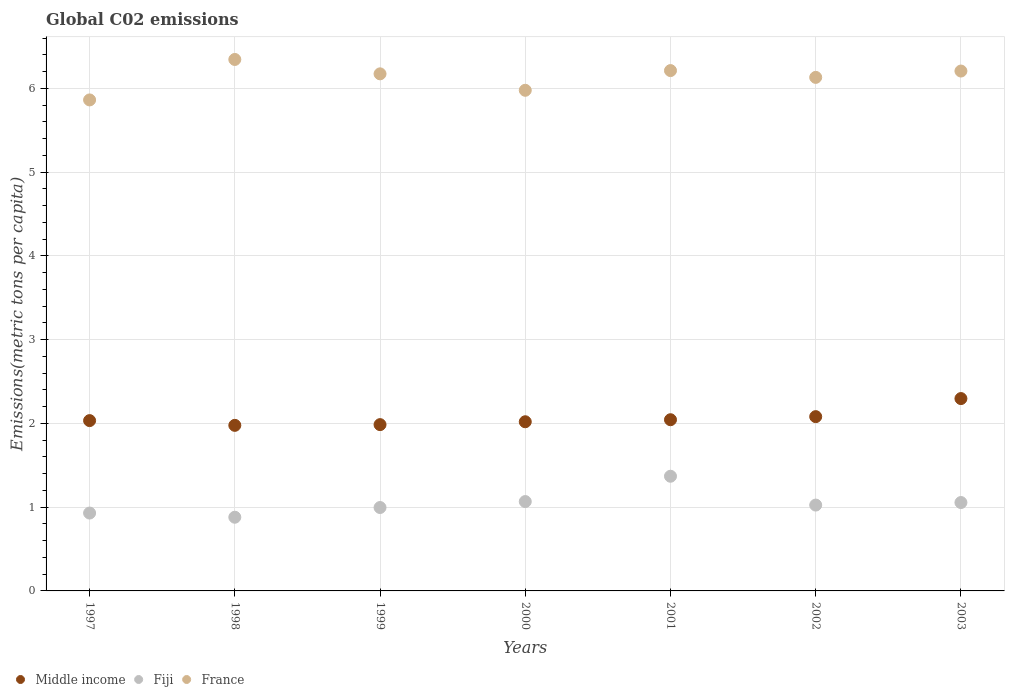How many different coloured dotlines are there?
Make the answer very short. 3. What is the amount of CO2 emitted in in Middle income in 2002?
Offer a terse response. 2.08. Across all years, what is the maximum amount of CO2 emitted in in Fiji?
Give a very brief answer. 1.37. Across all years, what is the minimum amount of CO2 emitted in in France?
Your answer should be compact. 5.86. What is the total amount of CO2 emitted in in Fiji in the graph?
Offer a very short reply. 7.32. What is the difference between the amount of CO2 emitted in in France in 1999 and that in 2001?
Your answer should be very brief. -0.04. What is the difference between the amount of CO2 emitted in in Middle income in 2003 and the amount of CO2 emitted in in France in 2001?
Provide a short and direct response. -3.92. What is the average amount of CO2 emitted in in Fiji per year?
Your answer should be compact. 1.05. In the year 2003, what is the difference between the amount of CO2 emitted in in Middle income and amount of CO2 emitted in in France?
Offer a terse response. -3.91. What is the ratio of the amount of CO2 emitted in in Middle income in 1999 to that in 2001?
Offer a terse response. 0.97. What is the difference between the highest and the second highest amount of CO2 emitted in in France?
Provide a short and direct response. 0.13. What is the difference between the highest and the lowest amount of CO2 emitted in in France?
Offer a very short reply. 0.48. In how many years, is the amount of CO2 emitted in in France greater than the average amount of CO2 emitted in in France taken over all years?
Your answer should be compact. 5. Does the amount of CO2 emitted in in France monotonically increase over the years?
Give a very brief answer. No. Is the amount of CO2 emitted in in Middle income strictly greater than the amount of CO2 emitted in in Fiji over the years?
Offer a terse response. Yes. Is the amount of CO2 emitted in in Fiji strictly less than the amount of CO2 emitted in in France over the years?
Offer a very short reply. Yes. How many dotlines are there?
Make the answer very short. 3. What is the difference between two consecutive major ticks on the Y-axis?
Offer a terse response. 1. Does the graph contain any zero values?
Provide a short and direct response. No. Does the graph contain grids?
Give a very brief answer. Yes. How are the legend labels stacked?
Your response must be concise. Horizontal. What is the title of the graph?
Offer a very short reply. Global C02 emissions. Does "Comoros" appear as one of the legend labels in the graph?
Give a very brief answer. No. What is the label or title of the X-axis?
Offer a terse response. Years. What is the label or title of the Y-axis?
Offer a very short reply. Emissions(metric tons per capita). What is the Emissions(metric tons per capita) in Middle income in 1997?
Your answer should be compact. 2.03. What is the Emissions(metric tons per capita) of Fiji in 1997?
Your response must be concise. 0.93. What is the Emissions(metric tons per capita) of France in 1997?
Offer a terse response. 5.86. What is the Emissions(metric tons per capita) in Middle income in 1998?
Offer a terse response. 1.98. What is the Emissions(metric tons per capita) of Fiji in 1998?
Make the answer very short. 0.88. What is the Emissions(metric tons per capita) in France in 1998?
Keep it short and to the point. 6.34. What is the Emissions(metric tons per capita) of Middle income in 1999?
Your answer should be compact. 1.99. What is the Emissions(metric tons per capita) of Fiji in 1999?
Offer a very short reply. 1. What is the Emissions(metric tons per capita) of France in 1999?
Offer a very short reply. 6.17. What is the Emissions(metric tons per capita) of Middle income in 2000?
Your answer should be compact. 2.02. What is the Emissions(metric tons per capita) of Fiji in 2000?
Give a very brief answer. 1.07. What is the Emissions(metric tons per capita) in France in 2000?
Your answer should be very brief. 5.98. What is the Emissions(metric tons per capita) in Middle income in 2001?
Give a very brief answer. 2.04. What is the Emissions(metric tons per capita) of Fiji in 2001?
Your response must be concise. 1.37. What is the Emissions(metric tons per capita) of France in 2001?
Keep it short and to the point. 6.21. What is the Emissions(metric tons per capita) of Middle income in 2002?
Your response must be concise. 2.08. What is the Emissions(metric tons per capita) in Fiji in 2002?
Your answer should be very brief. 1.02. What is the Emissions(metric tons per capita) in France in 2002?
Provide a short and direct response. 6.13. What is the Emissions(metric tons per capita) in Middle income in 2003?
Provide a succinct answer. 2.3. What is the Emissions(metric tons per capita) in Fiji in 2003?
Give a very brief answer. 1.06. What is the Emissions(metric tons per capita) of France in 2003?
Your answer should be compact. 6.21. Across all years, what is the maximum Emissions(metric tons per capita) in Middle income?
Offer a very short reply. 2.3. Across all years, what is the maximum Emissions(metric tons per capita) in Fiji?
Make the answer very short. 1.37. Across all years, what is the maximum Emissions(metric tons per capita) of France?
Your response must be concise. 6.34. Across all years, what is the minimum Emissions(metric tons per capita) of Middle income?
Make the answer very short. 1.98. Across all years, what is the minimum Emissions(metric tons per capita) in Fiji?
Provide a short and direct response. 0.88. Across all years, what is the minimum Emissions(metric tons per capita) in France?
Offer a very short reply. 5.86. What is the total Emissions(metric tons per capita) of Middle income in the graph?
Offer a very short reply. 14.44. What is the total Emissions(metric tons per capita) of Fiji in the graph?
Offer a terse response. 7.32. What is the total Emissions(metric tons per capita) in France in the graph?
Provide a short and direct response. 42.91. What is the difference between the Emissions(metric tons per capita) in Middle income in 1997 and that in 1998?
Provide a short and direct response. 0.06. What is the difference between the Emissions(metric tons per capita) of Fiji in 1997 and that in 1998?
Offer a terse response. 0.05. What is the difference between the Emissions(metric tons per capita) of France in 1997 and that in 1998?
Make the answer very short. -0.48. What is the difference between the Emissions(metric tons per capita) of Middle income in 1997 and that in 1999?
Keep it short and to the point. 0.05. What is the difference between the Emissions(metric tons per capita) of Fiji in 1997 and that in 1999?
Ensure brevity in your answer.  -0.07. What is the difference between the Emissions(metric tons per capita) of France in 1997 and that in 1999?
Your answer should be compact. -0.31. What is the difference between the Emissions(metric tons per capita) of Middle income in 1997 and that in 2000?
Keep it short and to the point. 0.01. What is the difference between the Emissions(metric tons per capita) in Fiji in 1997 and that in 2000?
Offer a very short reply. -0.14. What is the difference between the Emissions(metric tons per capita) in France in 1997 and that in 2000?
Provide a succinct answer. -0.11. What is the difference between the Emissions(metric tons per capita) of Middle income in 1997 and that in 2001?
Your response must be concise. -0.01. What is the difference between the Emissions(metric tons per capita) of Fiji in 1997 and that in 2001?
Keep it short and to the point. -0.44. What is the difference between the Emissions(metric tons per capita) of France in 1997 and that in 2001?
Provide a short and direct response. -0.35. What is the difference between the Emissions(metric tons per capita) in Middle income in 1997 and that in 2002?
Your response must be concise. -0.05. What is the difference between the Emissions(metric tons per capita) of Fiji in 1997 and that in 2002?
Give a very brief answer. -0.1. What is the difference between the Emissions(metric tons per capita) in France in 1997 and that in 2002?
Keep it short and to the point. -0.27. What is the difference between the Emissions(metric tons per capita) of Middle income in 1997 and that in 2003?
Your answer should be compact. -0.26. What is the difference between the Emissions(metric tons per capita) of Fiji in 1997 and that in 2003?
Your answer should be compact. -0.13. What is the difference between the Emissions(metric tons per capita) in France in 1997 and that in 2003?
Provide a succinct answer. -0.34. What is the difference between the Emissions(metric tons per capita) in Middle income in 1998 and that in 1999?
Your answer should be very brief. -0.01. What is the difference between the Emissions(metric tons per capita) in Fiji in 1998 and that in 1999?
Keep it short and to the point. -0.12. What is the difference between the Emissions(metric tons per capita) of France in 1998 and that in 1999?
Your answer should be compact. 0.17. What is the difference between the Emissions(metric tons per capita) of Middle income in 1998 and that in 2000?
Provide a succinct answer. -0.04. What is the difference between the Emissions(metric tons per capita) of Fiji in 1998 and that in 2000?
Your response must be concise. -0.19. What is the difference between the Emissions(metric tons per capita) in France in 1998 and that in 2000?
Offer a very short reply. 0.37. What is the difference between the Emissions(metric tons per capita) of Middle income in 1998 and that in 2001?
Offer a terse response. -0.07. What is the difference between the Emissions(metric tons per capita) in Fiji in 1998 and that in 2001?
Offer a terse response. -0.49. What is the difference between the Emissions(metric tons per capita) in France in 1998 and that in 2001?
Your answer should be compact. 0.13. What is the difference between the Emissions(metric tons per capita) in Middle income in 1998 and that in 2002?
Offer a terse response. -0.1. What is the difference between the Emissions(metric tons per capita) of Fiji in 1998 and that in 2002?
Your answer should be compact. -0.15. What is the difference between the Emissions(metric tons per capita) in France in 1998 and that in 2002?
Make the answer very short. 0.21. What is the difference between the Emissions(metric tons per capita) of Middle income in 1998 and that in 2003?
Your response must be concise. -0.32. What is the difference between the Emissions(metric tons per capita) of Fiji in 1998 and that in 2003?
Ensure brevity in your answer.  -0.18. What is the difference between the Emissions(metric tons per capita) of France in 1998 and that in 2003?
Provide a short and direct response. 0.14. What is the difference between the Emissions(metric tons per capita) of Middle income in 1999 and that in 2000?
Offer a terse response. -0.03. What is the difference between the Emissions(metric tons per capita) of Fiji in 1999 and that in 2000?
Your answer should be very brief. -0.07. What is the difference between the Emissions(metric tons per capita) in France in 1999 and that in 2000?
Give a very brief answer. 0.2. What is the difference between the Emissions(metric tons per capita) of Middle income in 1999 and that in 2001?
Give a very brief answer. -0.06. What is the difference between the Emissions(metric tons per capita) in Fiji in 1999 and that in 2001?
Your answer should be compact. -0.37. What is the difference between the Emissions(metric tons per capita) of France in 1999 and that in 2001?
Provide a short and direct response. -0.04. What is the difference between the Emissions(metric tons per capita) of Middle income in 1999 and that in 2002?
Keep it short and to the point. -0.1. What is the difference between the Emissions(metric tons per capita) in Fiji in 1999 and that in 2002?
Your response must be concise. -0.03. What is the difference between the Emissions(metric tons per capita) in France in 1999 and that in 2002?
Your response must be concise. 0.04. What is the difference between the Emissions(metric tons per capita) of Middle income in 1999 and that in 2003?
Your response must be concise. -0.31. What is the difference between the Emissions(metric tons per capita) in Fiji in 1999 and that in 2003?
Make the answer very short. -0.06. What is the difference between the Emissions(metric tons per capita) in France in 1999 and that in 2003?
Your response must be concise. -0.03. What is the difference between the Emissions(metric tons per capita) in Middle income in 2000 and that in 2001?
Your answer should be compact. -0.02. What is the difference between the Emissions(metric tons per capita) of Fiji in 2000 and that in 2001?
Ensure brevity in your answer.  -0.3. What is the difference between the Emissions(metric tons per capita) in France in 2000 and that in 2001?
Your answer should be very brief. -0.24. What is the difference between the Emissions(metric tons per capita) in Middle income in 2000 and that in 2002?
Keep it short and to the point. -0.06. What is the difference between the Emissions(metric tons per capita) of Fiji in 2000 and that in 2002?
Offer a very short reply. 0.04. What is the difference between the Emissions(metric tons per capita) in France in 2000 and that in 2002?
Offer a very short reply. -0.15. What is the difference between the Emissions(metric tons per capita) in Middle income in 2000 and that in 2003?
Keep it short and to the point. -0.28. What is the difference between the Emissions(metric tons per capita) of Fiji in 2000 and that in 2003?
Your response must be concise. 0.01. What is the difference between the Emissions(metric tons per capita) in France in 2000 and that in 2003?
Offer a terse response. -0.23. What is the difference between the Emissions(metric tons per capita) in Middle income in 2001 and that in 2002?
Keep it short and to the point. -0.04. What is the difference between the Emissions(metric tons per capita) of Fiji in 2001 and that in 2002?
Keep it short and to the point. 0.34. What is the difference between the Emissions(metric tons per capita) of France in 2001 and that in 2002?
Provide a short and direct response. 0.08. What is the difference between the Emissions(metric tons per capita) of Middle income in 2001 and that in 2003?
Provide a succinct answer. -0.25. What is the difference between the Emissions(metric tons per capita) of Fiji in 2001 and that in 2003?
Give a very brief answer. 0.31. What is the difference between the Emissions(metric tons per capita) in France in 2001 and that in 2003?
Ensure brevity in your answer.  0.01. What is the difference between the Emissions(metric tons per capita) in Middle income in 2002 and that in 2003?
Give a very brief answer. -0.22. What is the difference between the Emissions(metric tons per capita) in Fiji in 2002 and that in 2003?
Your answer should be compact. -0.03. What is the difference between the Emissions(metric tons per capita) in France in 2002 and that in 2003?
Your answer should be compact. -0.08. What is the difference between the Emissions(metric tons per capita) of Middle income in 1997 and the Emissions(metric tons per capita) of Fiji in 1998?
Offer a very short reply. 1.15. What is the difference between the Emissions(metric tons per capita) of Middle income in 1997 and the Emissions(metric tons per capita) of France in 1998?
Ensure brevity in your answer.  -4.31. What is the difference between the Emissions(metric tons per capita) of Fiji in 1997 and the Emissions(metric tons per capita) of France in 1998?
Provide a succinct answer. -5.42. What is the difference between the Emissions(metric tons per capita) in Middle income in 1997 and the Emissions(metric tons per capita) in Fiji in 1999?
Provide a succinct answer. 1.04. What is the difference between the Emissions(metric tons per capita) of Middle income in 1997 and the Emissions(metric tons per capita) of France in 1999?
Offer a terse response. -4.14. What is the difference between the Emissions(metric tons per capita) of Fiji in 1997 and the Emissions(metric tons per capita) of France in 1999?
Give a very brief answer. -5.24. What is the difference between the Emissions(metric tons per capita) of Middle income in 1997 and the Emissions(metric tons per capita) of Fiji in 2000?
Your answer should be compact. 0.97. What is the difference between the Emissions(metric tons per capita) in Middle income in 1997 and the Emissions(metric tons per capita) in France in 2000?
Ensure brevity in your answer.  -3.94. What is the difference between the Emissions(metric tons per capita) in Fiji in 1997 and the Emissions(metric tons per capita) in France in 2000?
Ensure brevity in your answer.  -5.05. What is the difference between the Emissions(metric tons per capita) in Middle income in 1997 and the Emissions(metric tons per capita) in Fiji in 2001?
Offer a very short reply. 0.66. What is the difference between the Emissions(metric tons per capita) of Middle income in 1997 and the Emissions(metric tons per capita) of France in 2001?
Keep it short and to the point. -4.18. What is the difference between the Emissions(metric tons per capita) of Fiji in 1997 and the Emissions(metric tons per capita) of France in 2001?
Provide a short and direct response. -5.28. What is the difference between the Emissions(metric tons per capita) in Middle income in 1997 and the Emissions(metric tons per capita) in Fiji in 2002?
Offer a very short reply. 1.01. What is the difference between the Emissions(metric tons per capita) of Middle income in 1997 and the Emissions(metric tons per capita) of France in 2002?
Your response must be concise. -4.1. What is the difference between the Emissions(metric tons per capita) in Fiji in 1997 and the Emissions(metric tons per capita) in France in 2002?
Provide a succinct answer. -5.2. What is the difference between the Emissions(metric tons per capita) in Middle income in 1997 and the Emissions(metric tons per capita) in France in 2003?
Provide a short and direct response. -4.17. What is the difference between the Emissions(metric tons per capita) in Fiji in 1997 and the Emissions(metric tons per capita) in France in 2003?
Provide a short and direct response. -5.28. What is the difference between the Emissions(metric tons per capita) in Middle income in 1998 and the Emissions(metric tons per capita) in Fiji in 1999?
Offer a very short reply. 0.98. What is the difference between the Emissions(metric tons per capita) of Middle income in 1998 and the Emissions(metric tons per capita) of France in 1999?
Offer a very short reply. -4.2. What is the difference between the Emissions(metric tons per capita) in Fiji in 1998 and the Emissions(metric tons per capita) in France in 1999?
Your answer should be very brief. -5.29. What is the difference between the Emissions(metric tons per capita) of Middle income in 1998 and the Emissions(metric tons per capita) of Fiji in 2000?
Offer a very short reply. 0.91. What is the difference between the Emissions(metric tons per capita) of Middle income in 1998 and the Emissions(metric tons per capita) of France in 2000?
Give a very brief answer. -4. What is the difference between the Emissions(metric tons per capita) of Fiji in 1998 and the Emissions(metric tons per capita) of France in 2000?
Ensure brevity in your answer.  -5.1. What is the difference between the Emissions(metric tons per capita) in Middle income in 1998 and the Emissions(metric tons per capita) in Fiji in 2001?
Give a very brief answer. 0.61. What is the difference between the Emissions(metric tons per capita) of Middle income in 1998 and the Emissions(metric tons per capita) of France in 2001?
Your answer should be compact. -4.24. What is the difference between the Emissions(metric tons per capita) of Fiji in 1998 and the Emissions(metric tons per capita) of France in 2001?
Your answer should be compact. -5.33. What is the difference between the Emissions(metric tons per capita) of Middle income in 1998 and the Emissions(metric tons per capita) of Fiji in 2002?
Give a very brief answer. 0.95. What is the difference between the Emissions(metric tons per capita) of Middle income in 1998 and the Emissions(metric tons per capita) of France in 2002?
Provide a succinct answer. -4.15. What is the difference between the Emissions(metric tons per capita) of Fiji in 1998 and the Emissions(metric tons per capita) of France in 2002?
Give a very brief answer. -5.25. What is the difference between the Emissions(metric tons per capita) of Middle income in 1998 and the Emissions(metric tons per capita) of Fiji in 2003?
Provide a short and direct response. 0.92. What is the difference between the Emissions(metric tons per capita) in Middle income in 1998 and the Emissions(metric tons per capita) in France in 2003?
Provide a succinct answer. -4.23. What is the difference between the Emissions(metric tons per capita) in Fiji in 1998 and the Emissions(metric tons per capita) in France in 2003?
Keep it short and to the point. -5.33. What is the difference between the Emissions(metric tons per capita) in Middle income in 1999 and the Emissions(metric tons per capita) in Fiji in 2000?
Ensure brevity in your answer.  0.92. What is the difference between the Emissions(metric tons per capita) in Middle income in 1999 and the Emissions(metric tons per capita) in France in 2000?
Ensure brevity in your answer.  -3.99. What is the difference between the Emissions(metric tons per capita) in Fiji in 1999 and the Emissions(metric tons per capita) in France in 2000?
Give a very brief answer. -4.98. What is the difference between the Emissions(metric tons per capita) in Middle income in 1999 and the Emissions(metric tons per capita) in Fiji in 2001?
Give a very brief answer. 0.62. What is the difference between the Emissions(metric tons per capita) in Middle income in 1999 and the Emissions(metric tons per capita) in France in 2001?
Give a very brief answer. -4.23. What is the difference between the Emissions(metric tons per capita) of Fiji in 1999 and the Emissions(metric tons per capita) of France in 2001?
Offer a very short reply. -5.22. What is the difference between the Emissions(metric tons per capita) in Middle income in 1999 and the Emissions(metric tons per capita) in Fiji in 2002?
Provide a short and direct response. 0.96. What is the difference between the Emissions(metric tons per capita) in Middle income in 1999 and the Emissions(metric tons per capita) in France in 2002?
Provide a short and direct response. -4.15. What is the difference between the Emissions(metric tons per capita) in Fiji in 1999 and the Emissions(metric tons per capita) in France in 2002?
Your answer should be very brief. -5.14. What is the difference between the Emissions(metric tons per capita) of Middle income in 1999 and the Emissions(metric tons per capita) of Fiji in 2003?
Provide a short and direct response. 0.93. What is the difference between the Emissions(metric tons per capita) in Middle income in 1999 and the Emissions(metric tons per capita) in France in 2003?
Your answer should be very brief. -4.22. What is the difference between the Emissions(metric tons per capita) of Fiji in 1999 and the Emissions(metric tons per capita) of France in 2003?
Provide a short and direct response. -5.21. What is the difference between the Emissions(metric tons per capita) of Middle income in 2000 and the Emissions(metric tons per capita) of Fiji in 2001?
Offer a very short reply. 0.65. What is the difference between the Emissions(metric tons per capita) in Middle income in 2000 and the Emissions(metric tons per capita) in France in 2001?
Give a very brief answer. -4.19. What is the difference between the Emissions(metric tons per capita) of Fiji in 2000 and the Emissions(metric tons per capita) of France in 2001?
Your answer should be very brief. -5.15. What is the difference between the Emissions(metric tons per capita) in Middle income in 2000 and the Emissions(metric tons per capita) in France in 2002?
Ensure brevity in your answer.  -4.11. What is the difference between the Emissions(metric tons per capita) of Fiji in 2000 and the Emissions(metric tons per capita) of France in 2002?
Keep it short and to the point. -5.06. What is the difference between the Emissions(metric tons per capita) in Middle income in 2000 and the Emissions(metric tons per capita) in Fiji in 2003?
Offer a very short reply. 0.96. What is the difference between the Emissions(metric tons per capita) of Middle income in 2000 and the Emissions(metric tons per capita) of France in 2003?
Keep it short and to the point. -4.19. What is the difference between the Emissions(metric tons per capita) of Fiji in 2000 and the Emissions(metric tons per capita) of France in 2003?
Offer a very short reply. -5.14. What is the difference between the Emissions(metric tons per capita) in Middle income in 2001 and the Emissions(metric tons per capita) in Fiji in 2002?
Ensure brevity in your answer.  1.02. What is the difference between the Emissions(metric tons per capita) of Middle income in 2001 and the Emissions(metric tons per capita) of France in 2002?
Your answer should be compact. -4.09. What is the difference between the Emissions(metric tons per capita) of Fiji in 2001 and the Emissions(metric tons per capita) of France in 2002?
Provide a short and direct response. -4.76. What is the difference between the Emissions(metric tons per capita) of Middle income in 2001 and the Emissions(metric tons per capita) of France in 2003?
Ensure brevity in your answer.  -4.16. What is the difference between the Emissions(metric tons per capita) of Fiji in 2001 and the Emissions(metric tons per capita) of France in 2003?
Give a very brief answer. -4.84. What is the difference between the Emissions(metric tons per capita) in Middle income in 2002 and the Emissions(metric tons per capita) in Fiji in 2003?
Provide a short and direct response. 1.03. What is the difference between the Emissions(metric tons per capita) of Middle income in 2002 and the Emissions(metric tons per capita) of France in 2003?
Make the answer very short. -4.13. What is the difference between the Emissions(metric tons per capita) in Fiji in 2002 and the Emissions(metric tons per capita) in France in 2003?
Provide a short and direct response. -5.18. What is the average Emissions(metric tons per capita) of Middle income per year?
Provide a succinct answer. 2.06. What is the average Emissions(metric tons per capita) in Fiji per year?
Provide a short and direct response. 1.05. What is the average Emissions(metric tons per capita) in France per year?
Provide a short and direct response. 6.13. In the year 1997, what is the difference between the Emissions(metric tons per capita) in Middle income and Emissions(metric tons per capita) in Fiji?
Keep it short and to the point. 1.1. In the year 1997, what is the difference between the Emissions(metric tons per capita) of Middle income and Emissions(metric tons per capita) of France?
Provide a short and direct response. -3.83. In the year 1997, what is the difference between the Emissions(metric tons per capita) of Fiji and Emissions(metric tons per capita) of France?
Provide a short and direct response. -4.93. In the year 1998, what is the difference between the Emissions(metric tons per capita) in Middle income and Emissions(metric tons per capita) in Fiji?
Offer a terse response. 1.1. In the year 1998, what is the difference between the Emissions(metric tons per capita) of Middle income and Emissions(metric tons per capita) of France?
Ensure brevity in your answer.  -4.37. In the year 1998, what is the difference between the Emissions(metric tons per capita) in Fiji and Emissions(metric tons per capita) in France?
Your response must be concise. -5.47. In the year 1999, what is the difference between the Emissions(metric tons per capita) of Middle income and Emissions(metric tons per capita) of France?
Your answer should be compact. -4.19. In the year 1999, what is the difference between the Emissions(metric tons per capita) of Fiji and Emissions(metric tons per capita) of France?
Provide a succinct answer. -5.18. In the year 2000, what is the difference between the Emissions(metric tons per capita) of Middle income and Emissions(metric tons per capita) of Fiji?
Give a very brief answer. 0.95. In the year 2000, what is the difference between the Emissions(metric tons per capita) in Middle income and Emissions(metric tons per capita) in France?
Offer a very short reply. -3.96. In the year 2000, what is the difference between the Emissions(metric tons per capita) in Fiji and Emissions(metric tons per capita) in France?
Offer a very short reply. -4.91. In the year 2001, what is the difference between the Emissions(metric tons per capita) of Middle income and Emissions(metric tons per capita) of Fiji?
Offer a very short reply. 0.67. In the year 2001, what is the difference between the Emissions(metric tons per capita) in Middle income and Emissions(metric tons per capita) in France?
Ensure brevity in your answer.  -4.17. In the year 2001, what is the difference between the Emissions(metric tons per capita) in Fiji and Emissions(metric tons per capita) in France?
Ensure brevity in your answer.  -4.84. In the year 2002, what is the difference between the Emissions(metric tons per capita) in Middle income and Emissions(metric tons per capita) in Fiji?
Your answer should be very brief. 1.06. In the year 2002, what is the difference between the Emissions(metric tons per capita) in Middle income and Emissions(metric tons per capita) in France?
Make the answer very short. -4.05. In the year 2002, what is the difference between the Emissions(metric tons per capita) in Fiji and Emissions(metric tons per capita) in France?
Provide a succinct answer. -5.11. In the year 2003, what is the difference between the Emissions(metric tons per capita) in Middle income and Emissions(metric tons per capita) in Fiji?
Keep it short and to the point. 1.24. In the year 2003, what is the difference between the Emissions(metric tons per capita) of Middle income and Emissions(metric tons per capita) of France?
Your answer should be compact. -3.91. In the year 2003, what is the difference between the Emissions(metric tons per capita) of Fiji and Emissions(metric tons per capita) of France?
Offer a very short reply. -5.15. What is the ratio of the Emissions(metric tons per capita) in Middle income in 1997 to that in 1998?
Your response must be concise. 1.03. What is the ratio of the Emissions(metric tons per capita) of Fiji in 1997 to that in 1998?
Provide a succinct answer. 1.06. What is the ratio of the Emissions(metric tons per capita) in France in 1997 to that in 1998?
Provide a short and direct response. 0.92. What is the ratio of the Emissions(metric tons per capita) of Middle income in 1997 to that in 1999?
Offer a terse response. 1.02. What is the ratio of the Emissions(metric tons per capita) of Fiji in 1997 to that in 1999?
Your response must be concise. 0.93. What is the ratio of the Emissions(metric tons per capita) in France in 1997 to that in 1999?
Give a very brief answer. 0.95. What is the ratio of the Emissions(metric tons per capita) of Middle income in 1997 to that in 2000?
Offer a terse response. 1.01. What is the ratio of the Emissions(metric tons per capita) of Fiji in 1997 to that in 2000?
Give a very brief answer. 0.87. What is the ratio of the Emissions(metric tons per capita) in France in 1997 to that in 2000?
Make the answer very short. 0.98. What is the ratio of the Emissions(metric tons per capita) in Middle income in 1997 to that in 2001?
Your answer should be very brief. 0.99. What is the ratio of the Emissions(metric tons per capita) of Fiji in 1997 to that in 2001?
Your answer should be very brief. 0.68. What is the ratio of the Emissions(metric tons per capita) in France in 1997 to that in 2001?
Offer a very short reply. 0.94. What is the ratio of the Emissions(metric tons per capita) of Middle income in 1997 to that in 2002?
Make the answer very short. 0.98. What is the ratio of the Emissions(metric tons per capita) in Fiji in 1997 to that in 2002?
Offer a terse response. 0.91. What is the ratio of the Emissions(metric tons per capita) in France in 1997 to that in 2002?
Offer a terse response. 0.96. What is the ratio of the Emissions(metric tons per capita) of Middle income in 1997 to that in 2003?
Give a very brief answer. 0.89. What is the ratio of the Emissions(metric tons per capita) in Fiji in 1997 to that in 2003?
Ensure brevity in your answer.  0.88. What is the ratio of the Emissions(metric tons per capita) in France in 1997 to that in 2003?
Give a very brief answer. 0.94. What is the ratio of the Emissions(metric tons per capita) of Middle income in 1998 to that in 1999?
Your answer should be compact. 1. What is the ratio of the Emissions(metric tons per capita) of Fiji in 1998 to that in 1999?
Provide a succinct answer. 0.88. What is the ratio of the Emissions(metric tons per capita) in France in 1998 to that in 1999?
Offer a terse response. 1.03. What is the ratio of the Emissions(metric tons per capita) in Middle income in 1998 to that in 2000?
Your answer should be very brief. 0.98. What is the ratio of the Emissions(metric tons per capita) of Fiji in 1998 to that in 2000?
Provide a short and direct response. 0.82. What is the ratio of the Emissions(metric tons per capita) in France in 1998 to that in 2000?
Your answer should be very brief. 1.06. What is the ratio of the Emissions(metric tons per capita) in Middle income in 1998 to that in 2001?
Your response must be concise. 0.97. What is the ratio of the Emissions(metric tons per capita) in Fiji in 1998 to that in 2001?
Keep it short and to the point. 0.64. What is the ratio of the Emissions(metric tons per capita) of France in 1998 to that in 2001?
Give a very brief answer. 1.02. What is the ratio of the Emissions(metric tons per capita) in Fiji in 1998 to that in 2002?
Provide a succinct answer. 0.86. What is the ratio of the Emissions(metric tons per capita) of France in 1998 to that in 2002?
Give a very brief answer. 1.03. What is the ratio of the Emissions(metric tons per capita) of Middle income in 1998 to that in 2003?
Offer a very short reply. 0.86. What is the ratio of the Emissions(metric tons per capita) of Fiji in 1998 to that in 2003?
Provide a short and direct response. 0.83. What is the ratio of the Emissions(metric tons per capita) of France in 1998 to that in 2003?
Your answer should be very brief. 1.02. What is the ratio of the Emissions(metric tons per capita) in Middle income in 1999 to that in 2000?
Make the answer very short. 0.98. What is the ratio of the Emissions(metric tons per capita) of Fiji in 1999 to that in 2000?
Keep it short and to the point. 0.93. What is the ratio of the Emissions(metric tons per capita) in France in 1999 to that in 2000?
Your answer should be very brief. 1.03. What is the ratio of the Emissions(metric tons per capita) in Middle income in 1999 to that in 2001?
Offer a terse response. 0.97. What is the ratio of the Emissions(metric tons per capita) in Fiji in 1999 to that in 2001?
Your answer should be very brief. 0.73. What is the ratio of the Emissions(metric tons per capita) in Middle income in 1999 to that in 2002?
Give a very brief answer. 0.95. What is the ratio of the Emissions(metric tons per capita) of Fiji in 1999 to that in 2002?
Ensure brevity in your answer.  0.97. What is the ratio of the Emissions(metric tons per capita) of France in 1999 to that in 2002?
Give a very brief answer. 1.01. What is the ratio of the Emissions(metric tons per capita) in Middle income in 1999 to that in 2003?
Your response must be concise. 0.86. What is the ratio of the Emissions(metric tons per capita) in Fiji in 1999 to that in 2003?
Provide a short and direct response. 0.94. What is the ratio of the Emissions(metric tons per capita) in France in 1999 to that in 2003?
Your answer should be very brief. 0.99. What is the ratio of the Emissions(metric tons per capita) of Fiji in 2000 to that in 2001?
Your answer should be compact. 0.78. What is the ratio of the Emissions(metric tons per capita) in France in 2000 to that in 2001?
Your answer should be compact. 0.96. What is the ratio of the Emissions(metric tons per capita) of Middle income in 2000 to that in 2002?
Offer a very short reply. 0.97. What is the ratio of the Emissions(metric tons per capita) in Fiji in 2000 to that in 2002?
Offer a very short reply. 1.04. What is the ratio of the Emissions(metric tons per capita) of France in 2000 to that in 2002?
Keep it short and to the point. 0.97. What is the ratio of the Emissions(metric tons per capita) of Middle income in 2000 to that in 2003?
Your answer should be very brief. 0.88. What is the ratio of the Emissions(metric tons per capita) in Fiji in 2000 to that in 2003?
Offer a very short reply. 1.01. What is the ratio of the Emissions(metric tons per capita) in Middle income in 2001 to that in 2002?
Make the answer very short. 0.98. What is the ratio of the Emissions(metric tons per capita) in Fiji in 2001 to that in 2002?
Your answer should be very brief. 1.34. What is the ratio of the Emissions(metric tons per capita) in France in 2001 to that in 2002?
Your response must be concise. 1.01. What is the ratio of the Emissions(metric tons per capita) in Middle income in 2001 to that in 2003?
Your answer should be compact. 0.89. What is the ratio of the Emissions(metric tons per capita) in Fiji in 2001 to that in 2003?
Your answer should be very brief. 1.3. What is the ratio of the Emissions(metric tons per capita) of Middle income in 2002 to that in 2003?
Your answer should be very brief. 0.91. What is the ratio of the Emissions(metric tons per capita) of Fiji in 2002 to that in 2003?
Provide a succinct answer. 0.97. What is the ratio of the Emissions(metric tons per capita) in France in 2002 to that in 2003?
Offer a very short reply. 0.99. What is the difference between the highest and the second highest Emissions(metric tons per capita) in Middle income?
Offer a very short reply. 0.22. What is the difference between the highest and the second highest Emissions(metric tons per capita) in Fiji?
Your answer should be very brief. 0.3. What is the difference between the highest and the second highest Emissions(metric tons per capita) of France?
Your response must be concise. 0.13. What is the difference between the highest and the lowest Emissions(metric tons per capita) of Middle income?
Keep it short and to the point. 0.32. What is the difference between the highest and the lowest Emissions(metric tons per capita) of Fiji?
Your answer should be very brief. 0.49. What is the difference between the highest and the lowest Emissions(metric tons per capita) in France?
Your answer should be compact. 0.48. 